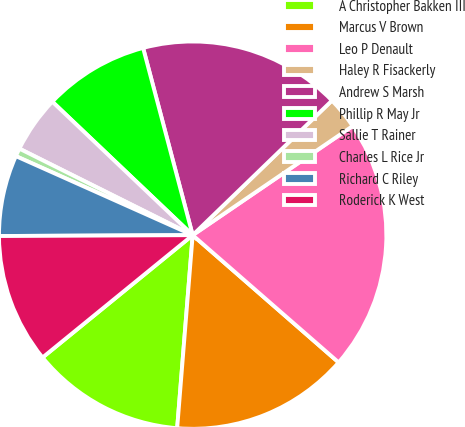<chart> <loc_0><loc_0><loc_500><loc_500><pie_chart><fcel>A Christopher Bakken III<fcel>Marcus V Brown<fcel>Leo P Denault<fcel>Haley R Fisackerly<fcel>Andrew S Marsh<fcel>Phillip R May Jr<fcel>Sallie T Rainer<fcel>Charles L Rice Jr<fcel>Richard C Riley<fcel>Roderick K West<nl><fcel>12.84%<fcel>14.86%<fcel>20.94%<fcel>2.7%<fcel>16.89%<fcel>8.78%<fcel>4.73%<fcel>0.68%<fcel>6.76%<fcel>10.81%<nl></chart> 